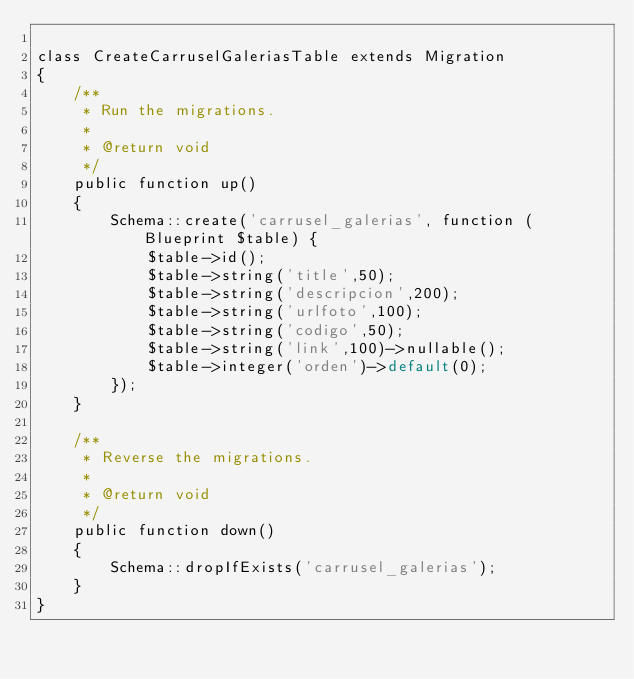<code> <loc_0><loc_0><loc_500><loc_500><_PHP_>
class CreateCarruselGaleriasTable extends Migration
{
    /**
     * Run the migrations.
     *
     * @return void
     */
    public function up()
    {
        Schema::create('carrusel_galerias', function (Blueprint $table) {
            $table->id();
            $table->string('title',50);
            $table->string('descripcion',200);
            $table->string('urlfoto',100);
            $table->string('codigo',50);
            $table->string('link',100)->nullable();
            $table->integer('orden')->default(0);
        });
    }

    /**
     * Reverse the migrations.
     *
     * @return void
     */
    public function down()
    {
        Schema::dropIfExists('carrusel_galerias');
    }
}
</code> 